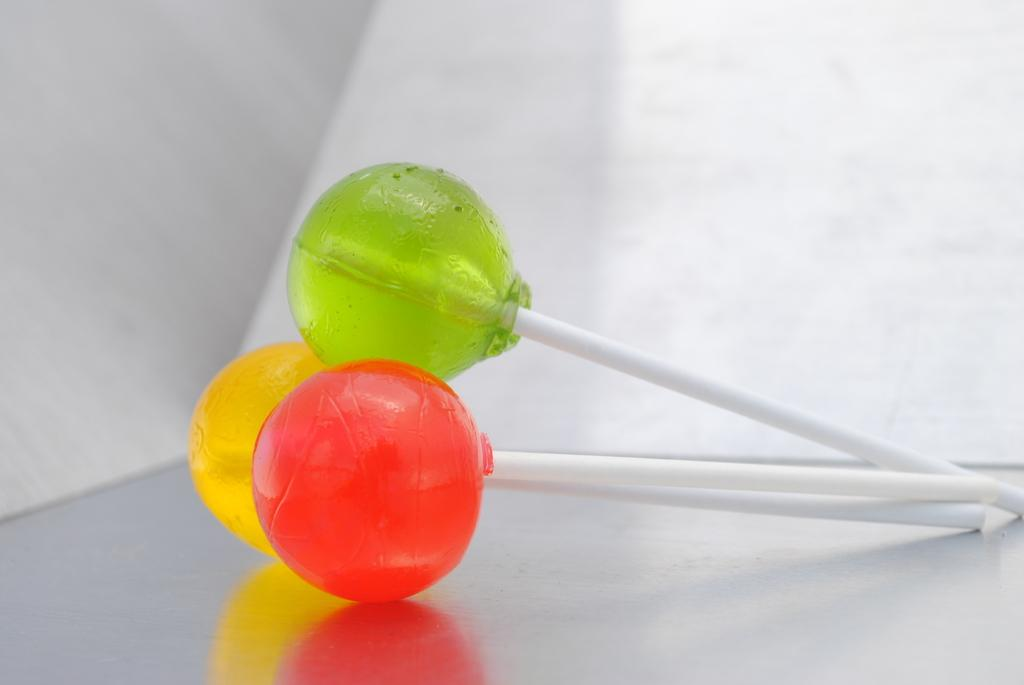What color lollipops can be seen in the image? There are yellow, red, and green lollipops in the image. How are the lollipops arranged in the image? The lollipops are placed on a surface. What is the color of the background in the image? The background of the image is white. Can you see a cat jumping over a lamp in the image? No, there is no cat or lamp present in the image. The image only features lollipops placed on a surface with a white background. 